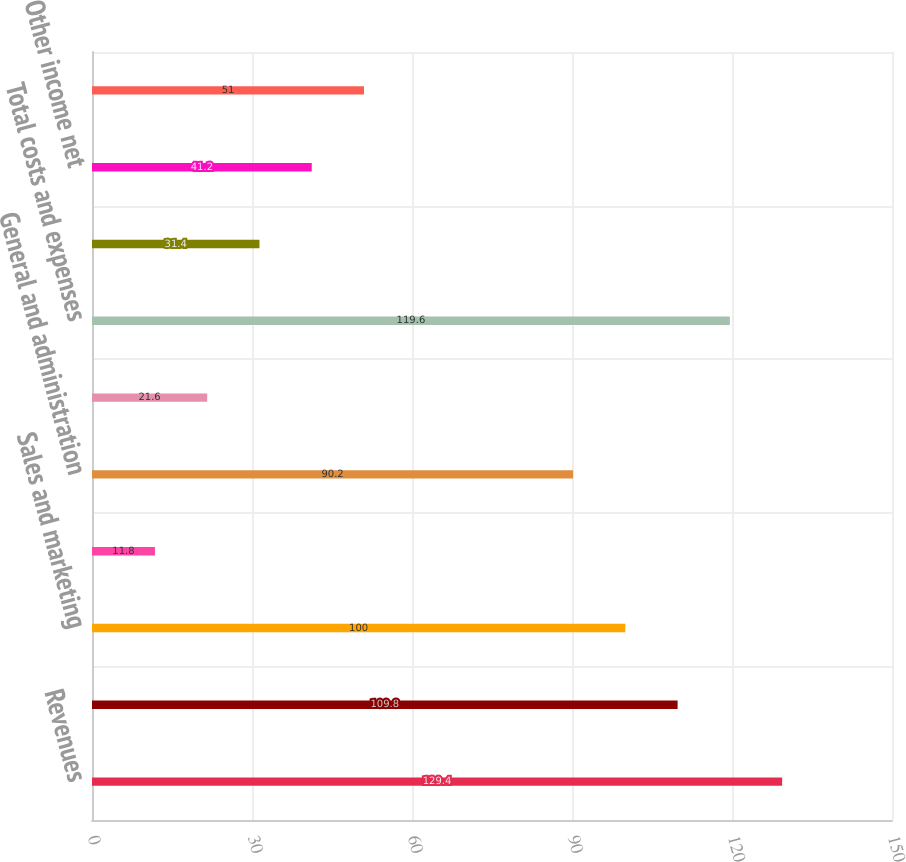Convert chart. <chart><loc_0><loc_0><loc_500><loc_500><bar_chart><fcel>Revenues<fcel>Cost of revenues<fcel>Sales and marketing<fcel>Research and development<fcel>General and administration<fcel>Amortization of other<fcel>Total costs and expenses<fcel>Operating income from<fcel>Other income net<fcel>Total other income net<nl><fcel>129.4<fcel>109.8<fcel>100<fcel>11.8<fcel>90.2<fcel>21.6<fcel>119.6<fcel>31.4<fcel>41.2<fcel>51<nl></chart> 